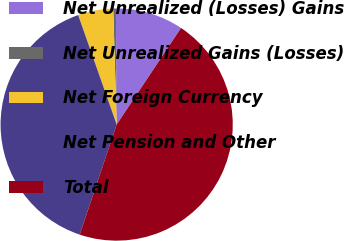Convert chart to OTSL. <chart><loc_0><loc_0><loc_500><loc_500><pie_chart><fcel>Net Unrealized (Losses) Gains<fcel>Net Unrealized Gains (Losses)<fcel>Net Foreign Currency<fcel>Net Pension and Other<fcel>Total<nl><fcel>9.46%<fcel>0.37%<fcel>4.91%<fcel>39.46%<fcel>45.8%<nl></chart> 